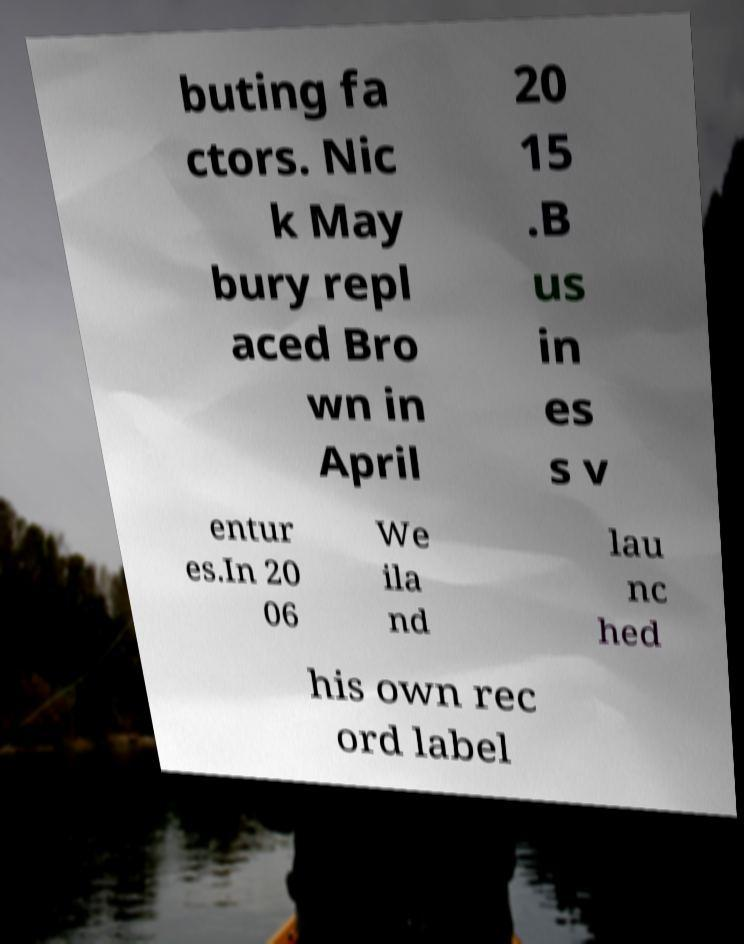For documentation purposes, I need the text within this image transcribed. Could you provide that? buting fa ctors. Nic k May bury repl aced Bro wn in April 20 15 .B us in es s v entur es.In 20 06 We ila nd lau nc hed his own rec ord label 